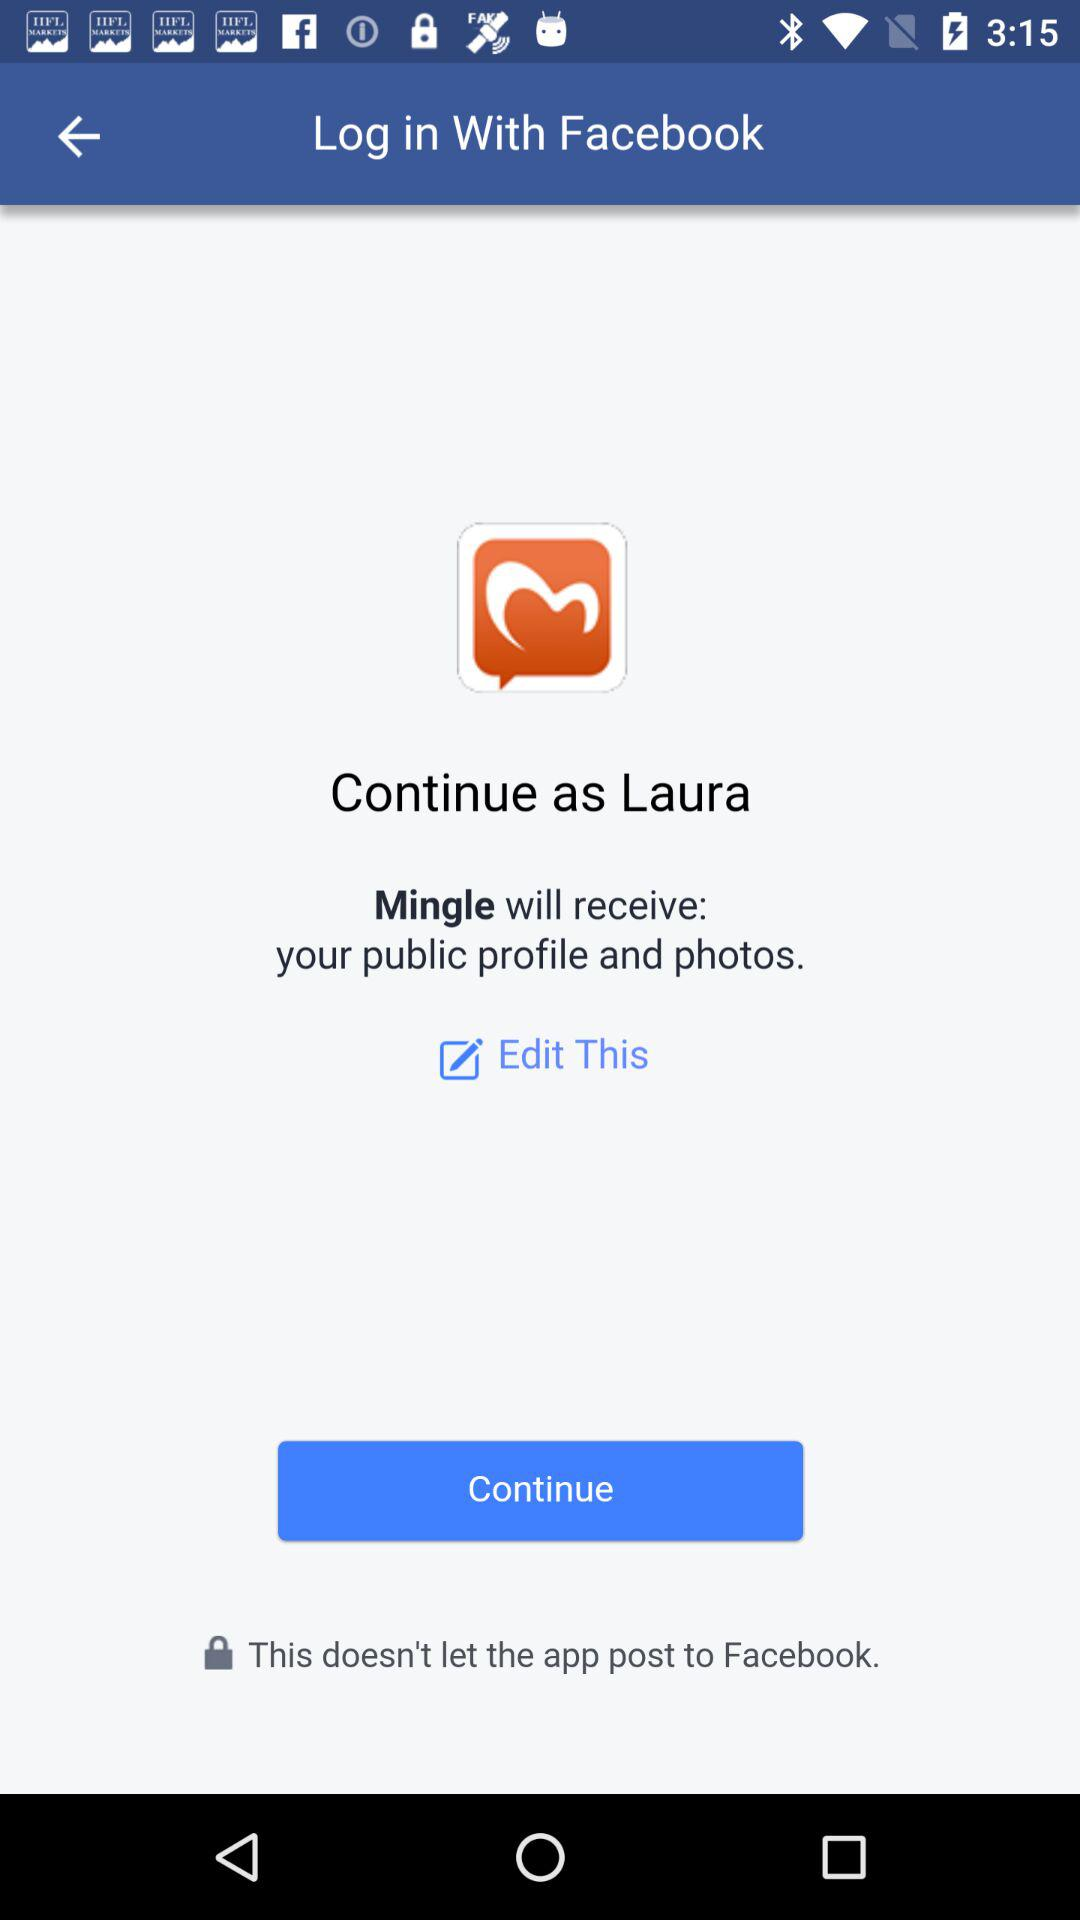How can we log in? You can log in with "Facebook". 